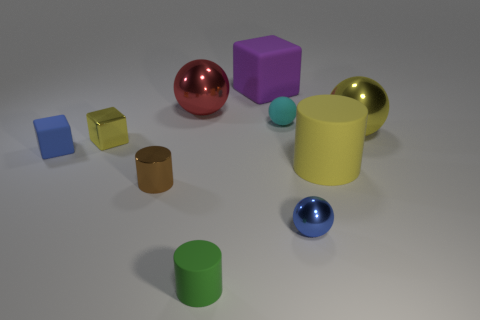There is a yellow object in front of the matte cube in front of the yellow shiny object right of the cyan matte ball; how big is it? The yellow object positioned in front of the matte cube, itself located in front of another shiny yellow object adjacent to the cyan matte ball, appears to be small in size, relative to the other objects around it. 